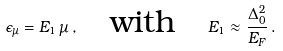<formula> <loc_0><loc_0><loc_500><loc_500>\epsilon _ { \mu } = E _ { 1 } \, \mu \, , \quad \text {with} \quad E _ { 1 } \approx \frac { \Delta _ { 0 } ^ { 2 } } { E _ { F } } \, .</formula> 